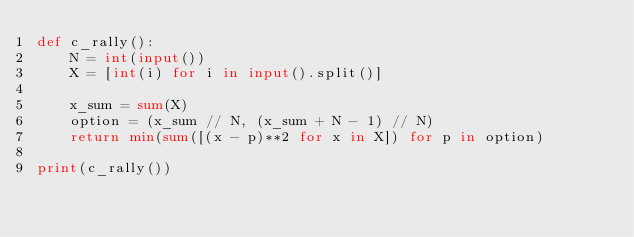<code> <loc_0><loc_0><loc_500><loc_500><_Python_>def c_rally():
    N = int(input())
    X = [int(i) for i in input().split()]

    x_sum = sum(X)
    option = (x_sum // N, (x_sum + N - 1) // N)
    return min(sum([(x - p)**2 for x in X]) for p in option)

print(c_rally())</code> 